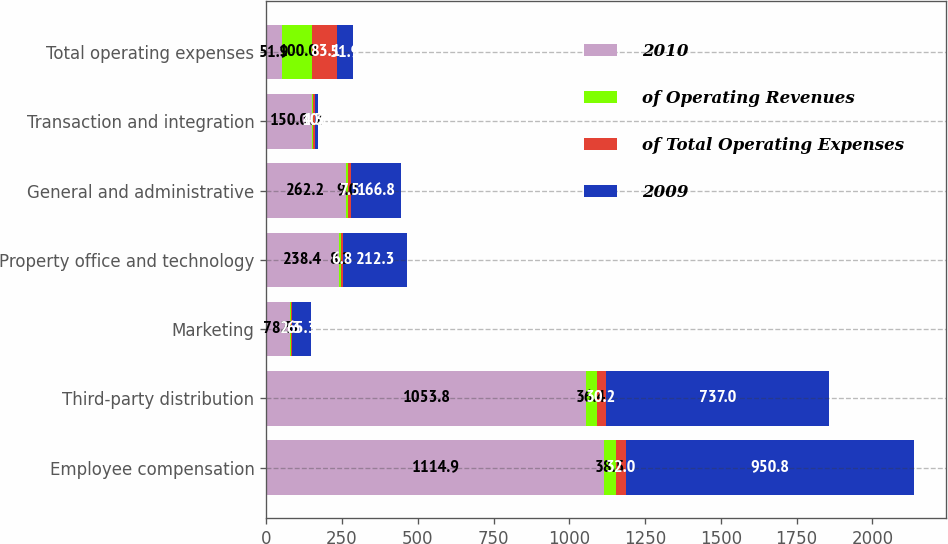Convert chart to OTSL. <chart><loc_0><loc_0><loc_500><loc_500><stacked_bar_chart><ecel><fcel>Employee compensation<fcel>Third-party distribution<fcel>Marketing<fcel>Property office and technology<fcel>General and administrative<fcel>Transaction and integration<fcel>Total operating expenses<nl><fcel>2010<fcel>1114.9<fcel>1053.8<fcel>78.5<fcel>238.4<fcel>262.2<fcel>150<fcel>51.9<nl><fcel>of Operating Revenues<fcel>38.5<fcel>36.4<fcel>2.7<fcel>8.2<fcel>9<fcel>5.2<fcel>100<nl><fcel>of Total Operating Expenses<fcel>32<fcel>30.2<fcel>2.3<fcel>6.8<fcel>7.5<fcel>4.3<fcel>83.1<nl><fcel>2009<fcel>950.8<fcel>737<fcel>65.3<fcel>212.3<fcel>166.8<fcel>10.8<fcel>51.9<nl></chart> 